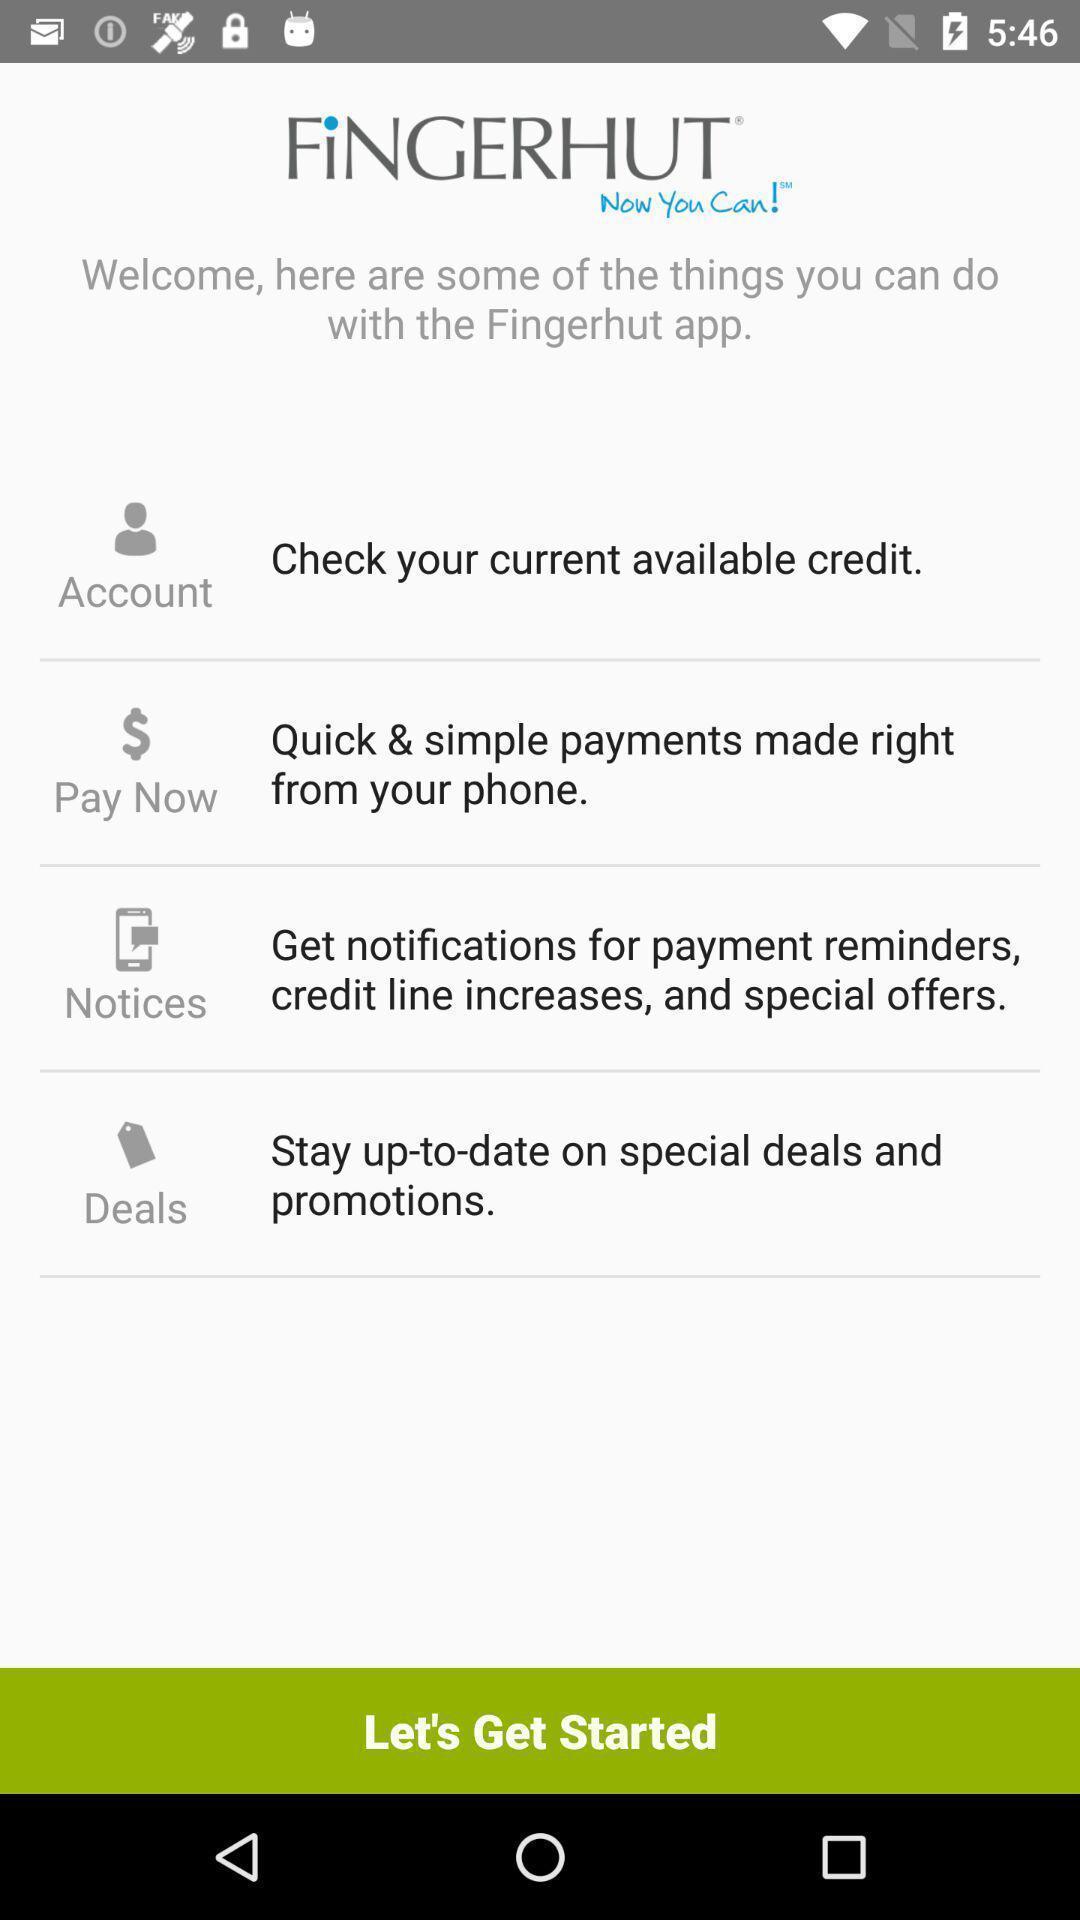Describe the key features of this screenshot. Welcome page of a payment application. 